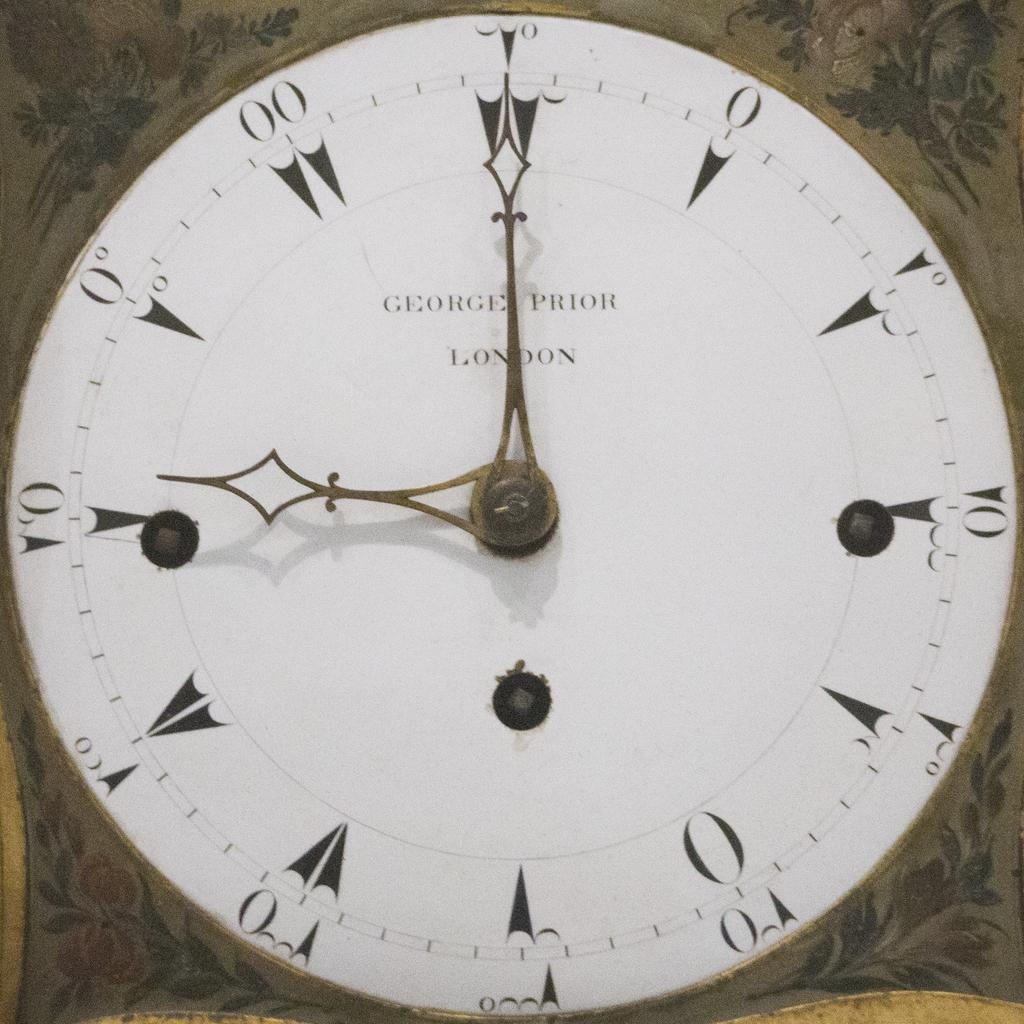<image>
Render a clear and concise summary of the photo. A George Prior London clock that says nine o clock 